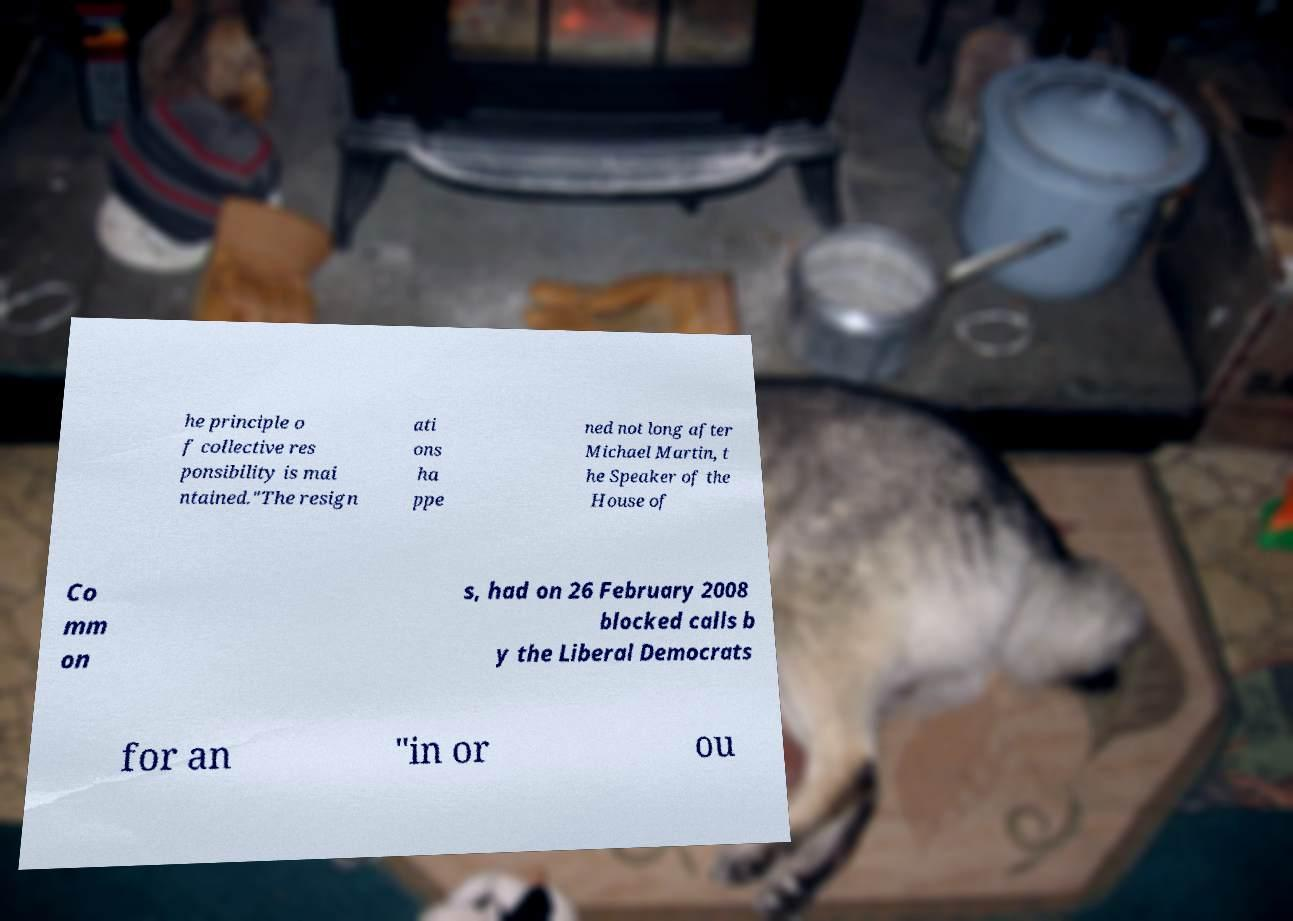Please read and relay the text visible in this image. What does it say? he principle o f collective res ponsibility is mai ntained."The resign ati ons ha ppe ned not long after Michael Martin, t he Speaker of the House of Co mm on s, had on 26 February 2008 blocked calls b y the Liberal Democrats for an "in or ou 